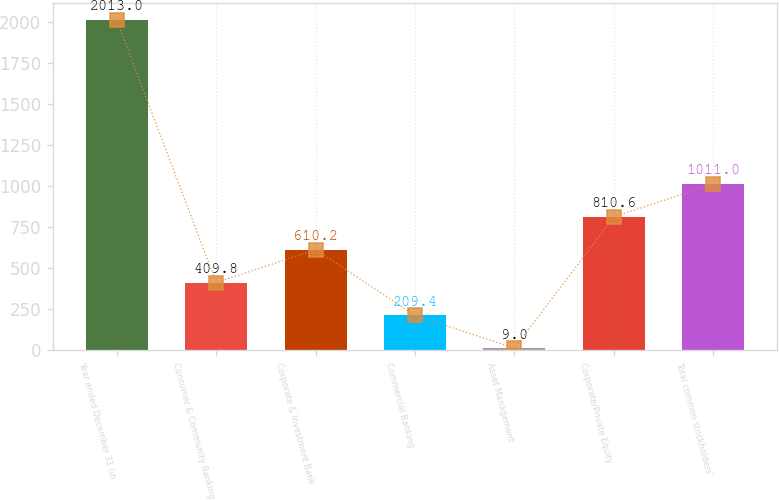Convert chart to OTSL. <chart><loc_0><loc_0><loc_500><loc_500><bar_chart><fcel>Year ended December 31 (in<fcel>Consumer & Community Banking<fcel>Corporate & Investment Bank<fcel>Commercial Banking<fcel>Asset Management<fcel>Corporate/Private Equity<fcel>Total common stockholders'<nl><fcel>2013<fcel>409.8<fcel>610.2<fcel>209.4<fcel>9<fcel>810.6<fcel>1011<nl></chart> 